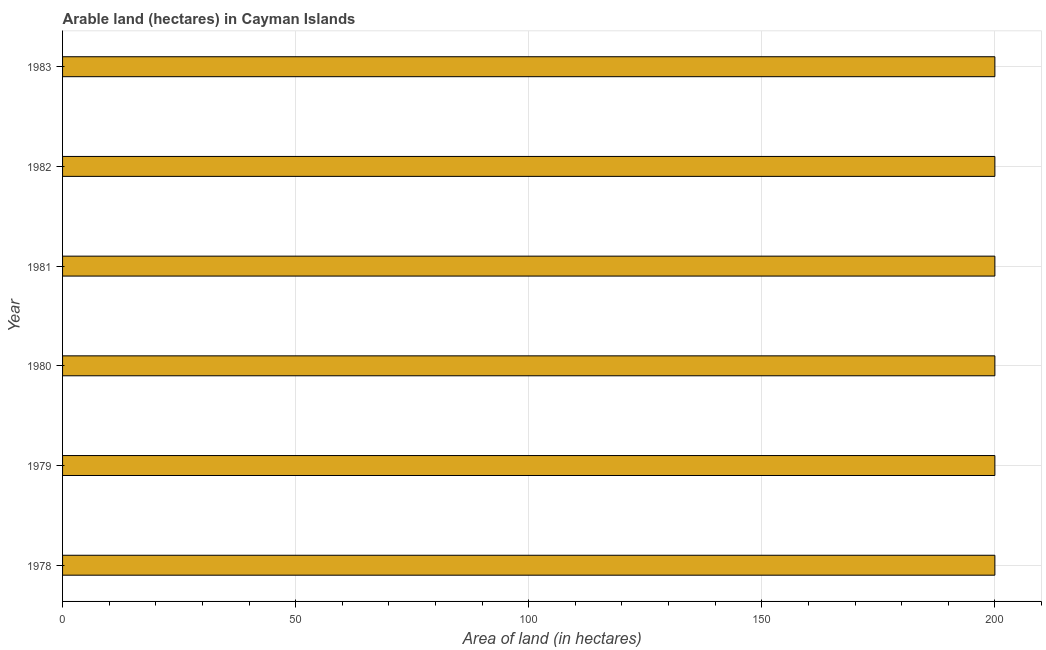Does the graph contain grids?
Your response must be concise. Yes. What is the title of the graph?
Give a very brief answer. Arable land (hectares) in Cayman Islands. What is the label or title of the X-axis?
Provide a short and direct response. Area of land (in hectares). What is the area of land in 1981?
Offer a very short reply. 200. In which year was the area of land maximum?
Offer a terse response. 1978. In which year was the area of land minimum?
Offer a very short reply. 1978. What is the sum of the area of land?
Keep it short and to the point. 1200. What is the average area of land per year?
Give a very brief answer. 200. Do a majority of the years between 1983 and 1978 (inclusive) have area of land greater than 160 hectares?
Your answer should be compact. Yes. Is the sum of the area of land in 1982 and 1983 greater than the maximum area of land across all years?
Give a very brief answer. Yes. How many bars are there?
Provide a succinct answer. 6. How many years are there in the graph?
Provide a short and direct response. 6. What is the difference between two consecutive major ticks on the X-axis?
Keep it short and to the point. 50. Are the values on the major ticks of X-axis written in scientific E-notation?
Your answer should be very brief. No. What is the Area of land (in hectares) of 1978?
Provide a short and direct response. 200. What is the Area of land (in hectares) in 1982?
Make the answer very short. 200. What is the difference between the Area of land (in hectares) in 1978 and 1982?
Provide a short and direct response. 0. What is the difference between the Area of land (in hectares) in 1978 and 1983?
Offer a very short reply. 0. What is the difference between the Area of land (in hectares) in 1979 and 1980?
Provide a short and direct response. 0. What is the difference between the Area of land (in hectares) in 1979 and 1982?
Your answer should be compact. 0. What is the difference between the Area of land (in hectares) in 1979 and 1983?
Provide a short and direct response. 0. What is the difference between the Area of land (in hectares) in 1980 and 1983?
Provide a succinct answer. 0. What is the difference between the Area of land (in hectares) in 1981 and 1983?
Ensure brevity in your answer.  0. What is the ratio of the Area of land (in hectares) in 1978 to that in 1982?
Ensure brevity in your answer.  1. What is the ratio of the Area of land (in hectares) in 1978 to that in 1983?
Provide a succinct answer. 1. What is the ratio of the Area of land (in hectares) in 1979 to that in 1981?
Offer a terse response. 1. What is the ratio of the Area of land (in hectares) in 1979 to that in 1983?
Offer a terse response. 1. What is the ratio of the Area of land (in hectares) in 1980 to that in 1982?
Your answer should be compact. 1. What is the ratio of the Area of land (in hectares) in 1981 to that in 1982?
Give a very brief answer. 1. 